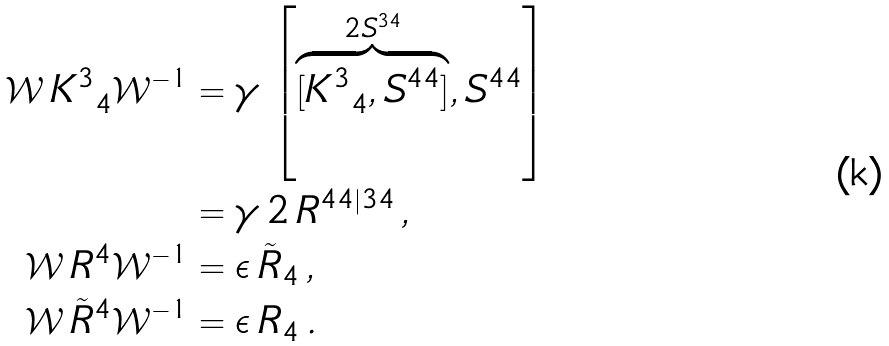<formula> <loc_0><loc_0><loc_500><loc_500>\mathcal { W } \, K ^ { 3 } _ { \ 4 } \mathcal { W } ^ { - 1 } & = \gamma \, \left [ \overbrace { [ K ^ { 3 } _ { \ 4 } , S ^ { 4 4 } ] } ^ { 2 S ^ { 3 4 } } , S ^ { 4 4 } \right ] \\ \ & = \gamma \, 2 \, R ^ { 4 4 | 3 4 } \, , \\ \mathcal { W } \, R ^ { 4 } \mathcal { W } ^ { - 1 } & = \epsilon \, \tilde { R } _ { 4 } \, , \\ \mathcal { W } \, \tilde { R } ^ { 4 } \mathcal { W } ^ { - 1 } & = \epsilon \, R _ { 4 } \, .</formula> 